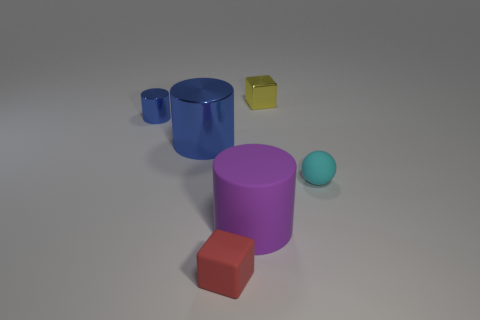Subtract all large cylinders. How many cylinders are left? 1 Subtract all purple cylinders. How many cylinders are left? 2 Subtract 1 balls. How many balls are left? 0 Add 3 green matte things. How many objects exist? 9 Subtract all red cylinders. How many red blocks are left? 1 Subtract 0 green balls. How many objects are left? 6 Subtract all cubes. How many objects are left? 4 Subtract all blue cylinders. Subtract all gray blocks. How many cylinders are left? 1 Subtract all big purple things. Subtract all tiny cyan rubber spheres. How many objects are left? 4 Add 5 purple rubber things. How many purple rubber things are left? 6 